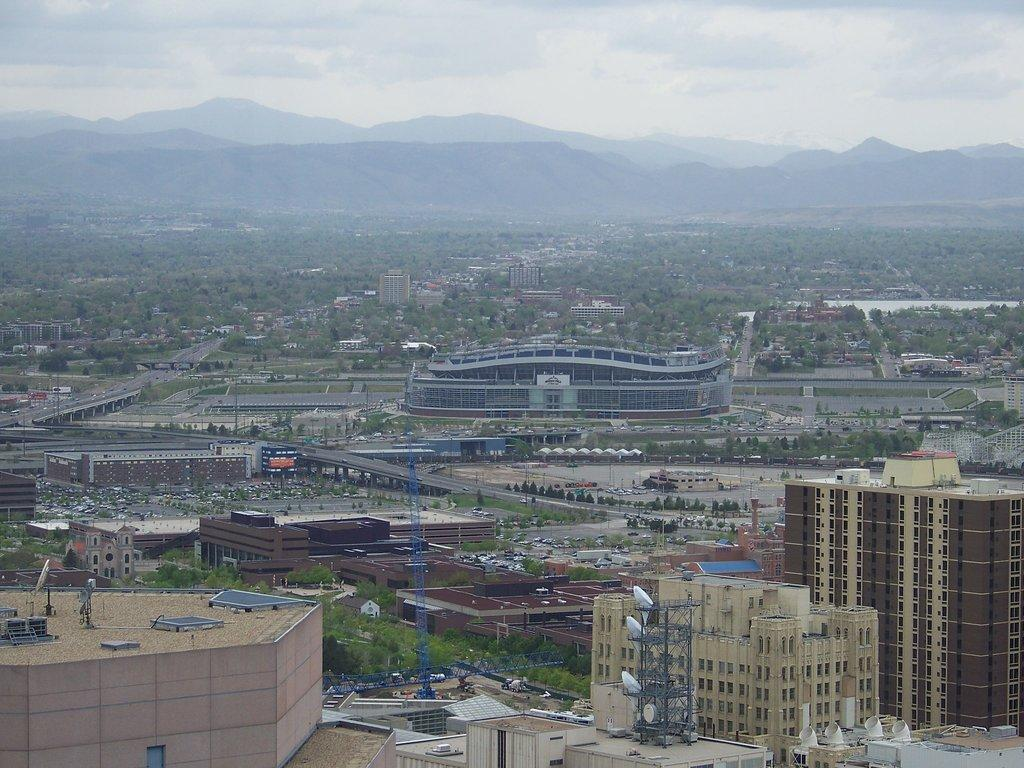What type of structures can be seen in the image? There are many buildings in the image. What feature is visible on the buildings? There are windows visible on the buildings. What type of natural elements can be seen in the image? There are trees in the image. What object is present in the image that might be used for support or signage? There is a pole in the image. What type of man-made objects are present in the image? There are vehicles in the image. What type of pathway is visible in the image? There is a road in the image. What type of geographical feature can be seen in the image? There is a mountain in the image. What is the condition of the sky in the image? The sky is cloudy in the image. Can you tell me how many sticks of butter are on the mountain in the image? There is no butter present in the image, and therefore no such items can be counted on the mountain. What type of bird is shown interacting with the vehicles on the road in the image? There are no birds, including ducks, shown interacting with the vehicles on the road in the image. 